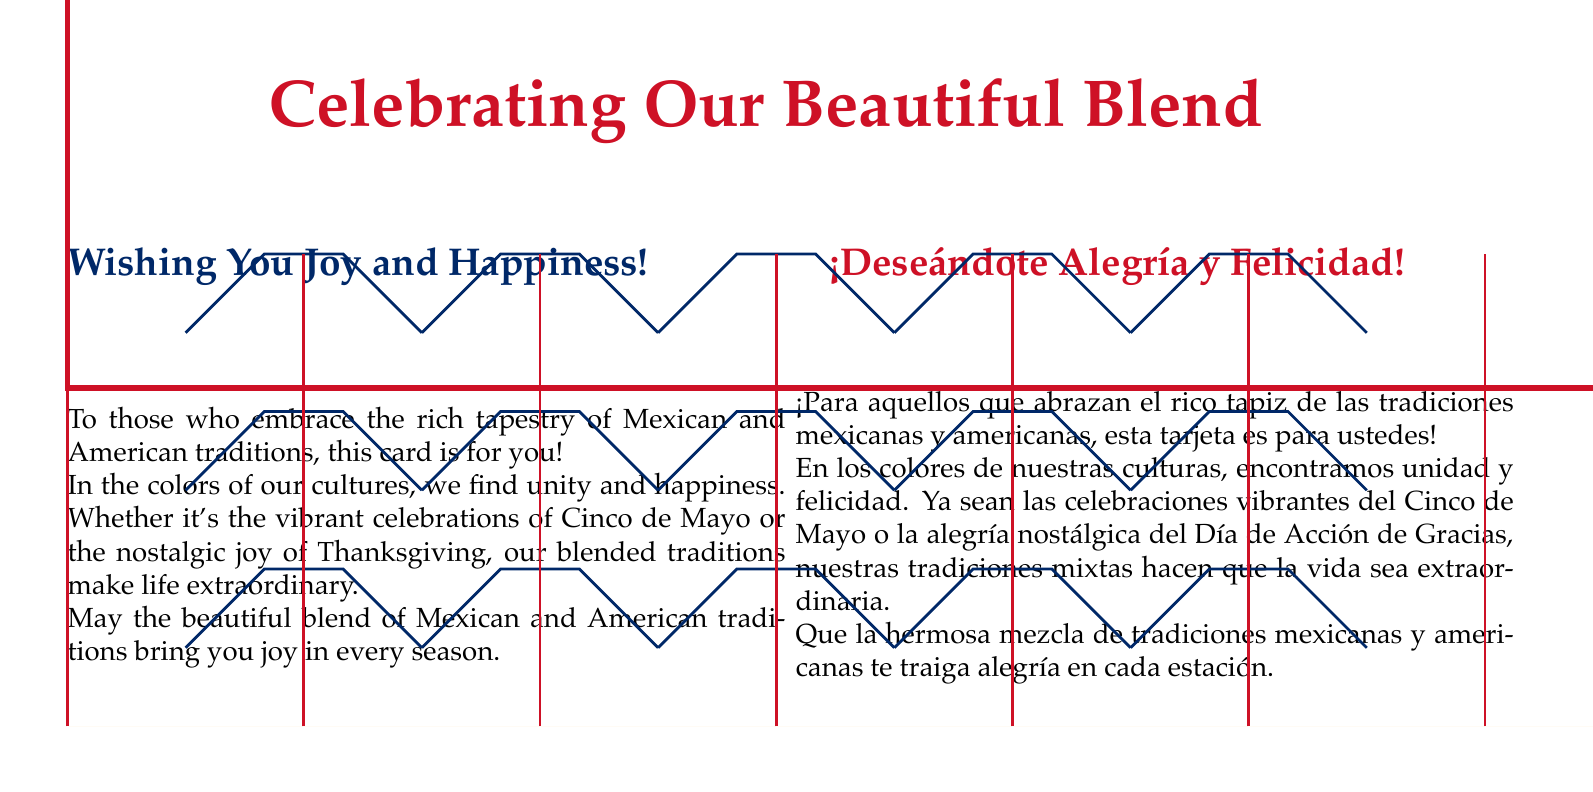What is the title of the card? The title is located at the top of the card and expresses the theme of the document.
Answer: Celebrating Our Beautiful Blend What are the colors used in the card? The colors are mentioned in the definitions and are reflected in the card’s design.
Answer: Mexican Red, USA Blue, Marigold How many languages are used in the greeting? The card includes multiple messages in both languages, making it bilingual.
Answer: Two What occasions are mentioned in the card? The text discusses specific cultural events that are celebrated in both traditions.
Answer: Cinco de Mayo and Thanksgiving What is the overall message of the card? The card communicates a theme of unity and joy through cultural blending.
Answer: Joy and Happiness What is the opacity level of the Marigold color in the background? The opacity level is noted in the design specifications of the card.
Answer: 0.3 Which culture's colors are symbolized by Mexican Red? The color symbolization is explained in terms of cultural significance within the document.
Answer: Mexican culture What is the font used for the text in the card? The font is specified at the beginning of the code, outlining the card's text style.
Answer: Palatino What is the main purpose of this card? The purpose is highlighted through the greeting and the cultural references within the text.
Answer: To celebrate the blend of traditions 